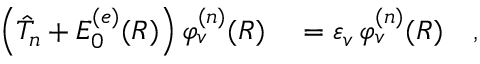Convert formula to latex. <formula><loc_0><loc_0><loc_500><loc_500>\begin{array} { r l } { \left ( \hat { T } _ { n } + E _ { 0 } ^ { ( e ) } ( R ) \right ) \varphi _ { v } ^ { ( n ) } ( R ) } & = \varepsilon _ { v } \, \varphi _ { v } ^ { ( n ) } ( R ) \quad , } \end{array}</formula> 